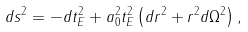Convert formula to latex. <formula><loc_0><loc_0><loc_500><loc_500>d s ^ { 2 } = - d t _ { E } ^ { 2 } + a _ { 0 } ^ { 2 } t _ { E } ^ { 2 } \left ( d r ^ { 2 } + r ^ { 2 } d \Omega ^ { 2 } \right ) ,</formula> 